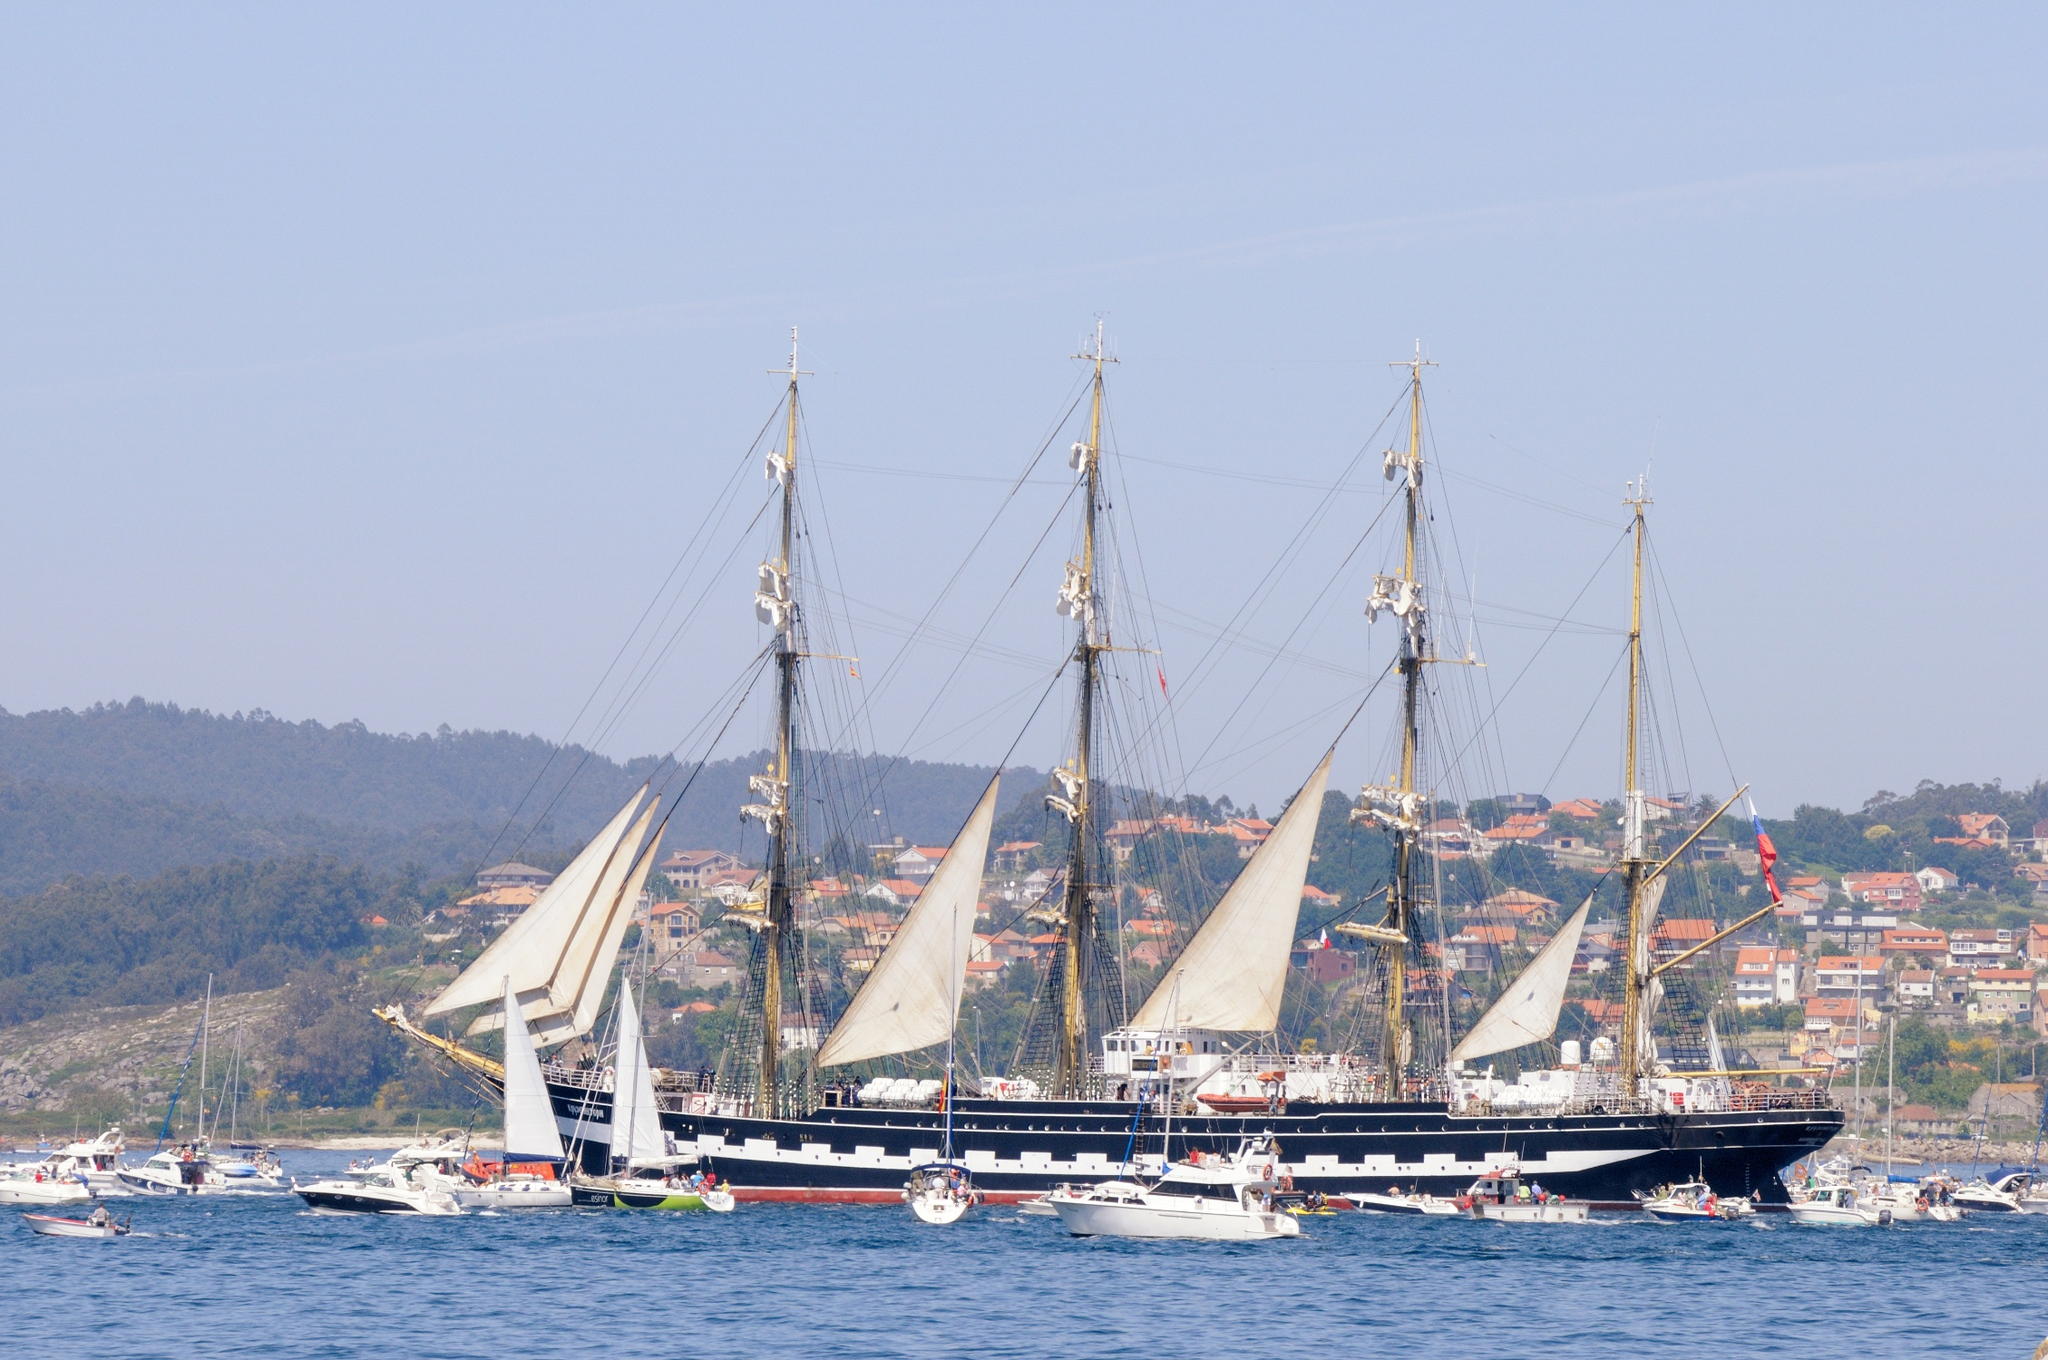Can you tell me more about the history and purpose of ships like the one in the image? Ships like the one pictured were historically used for ocean-going trade, naval warfare, exploration, and transportation of goods over long distances. Today, such vessels are often preserved and used for educational purposes, training aspiring sailors, celebrating nautical history, or serving as museum ships to convey the maritime culture and navigation techniques of the past. 